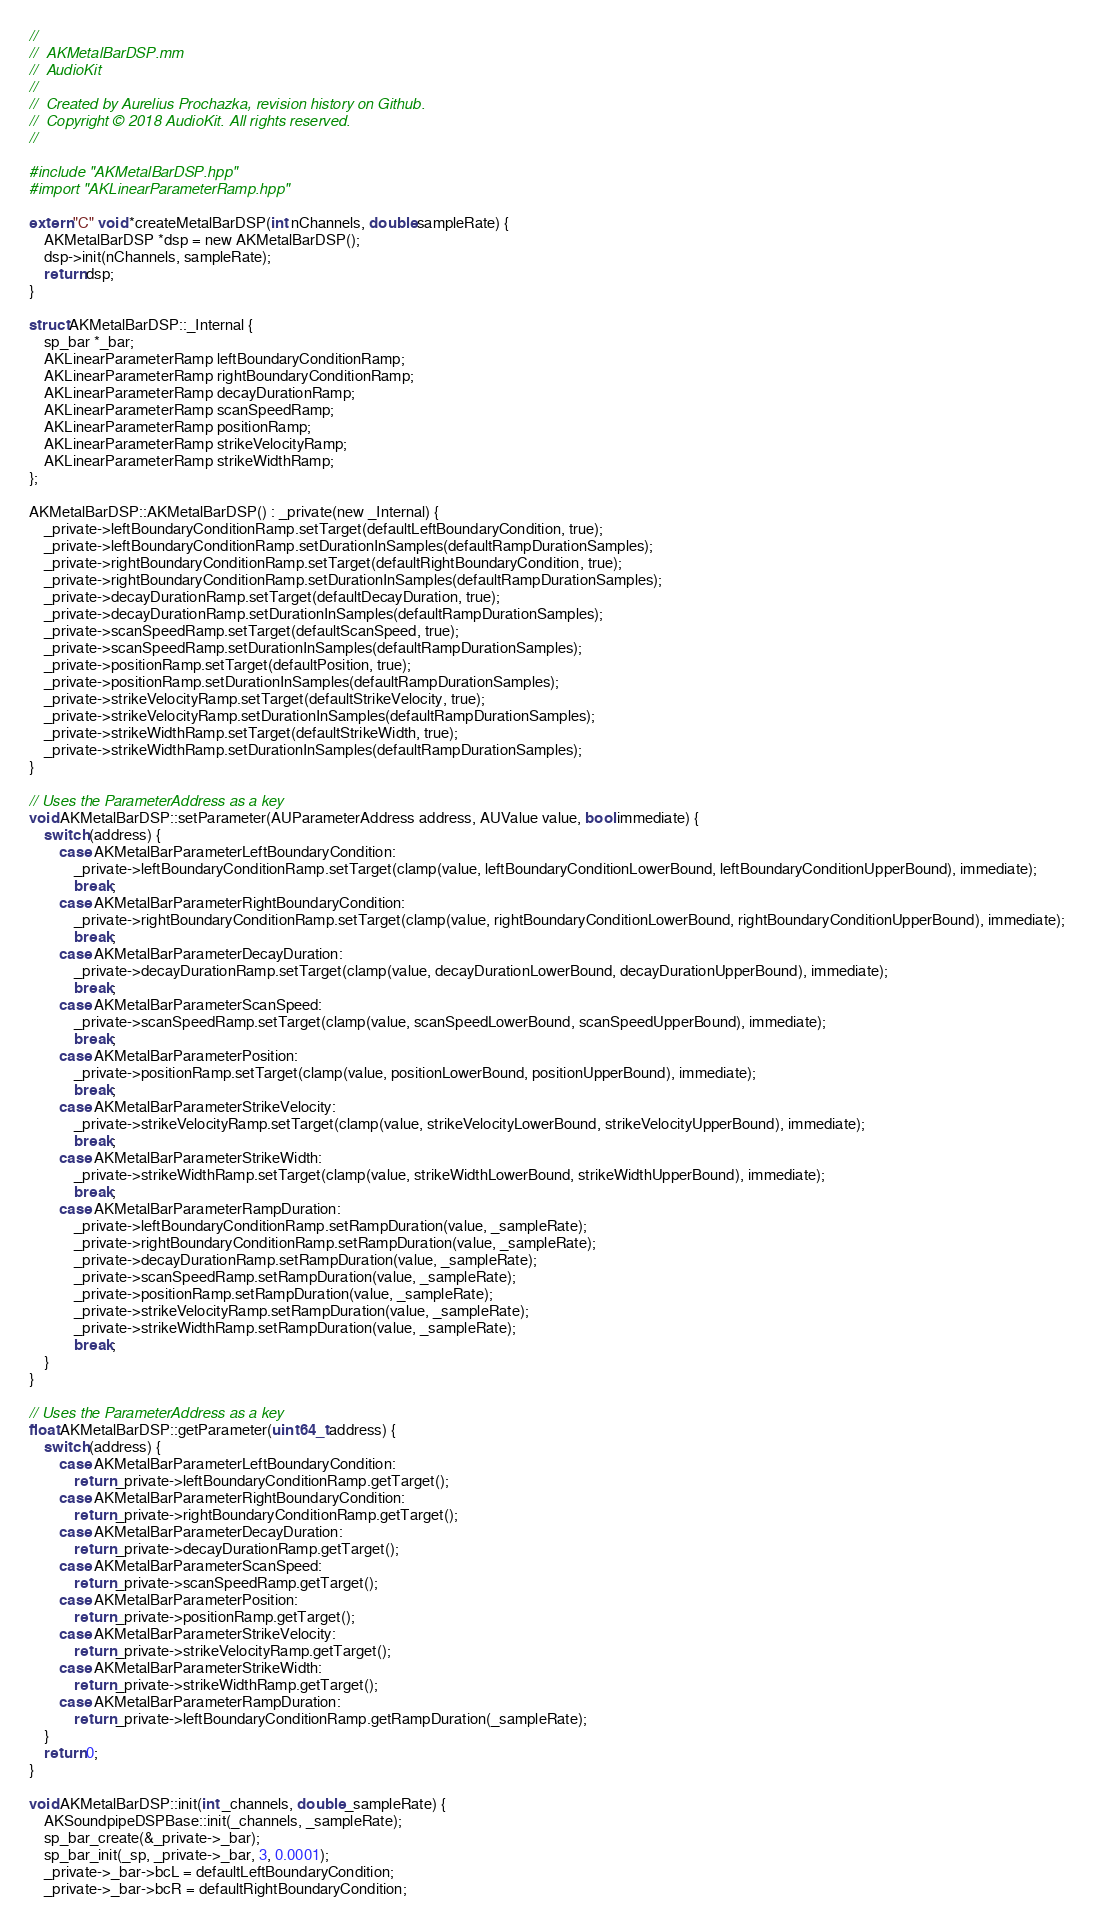<code> <loc_0><loc_0><loc_500><loc_500><_ObjectiveC_>//
//  AKMetalBarDSP.mm
//  AudioKit
//
//  Created by Aurelius Prochazka, revision history on Github.
//  Copyright © 2018 AudioKit. All rights reserved.
//

#include "AKMetalBarDSP.hpp"
#import "AKLinearParameterRamp.hpp"

extern "C" void *createMetalBarDSP(int nChannels, double sampleRate) {
    AKMetalBarDSP *dsp = new AKMetalBarDSP();
    dsp->init(nChannels, sampleRate);
    return dsp;
}

struct AKMetalBarDSP::_Internal {
    sp_bar *_bar;
    AKLinearParameterRamp leftBoundaryConditionRamp;
    AKLinearParameterRamp rightBoundaryConditionRamp;
    AKLinearParameterRamp decayDurationRamp;
    AKLinearParameterRamp scanSpeedRamp;
    AKLinearParameterRamp positionRamp;
    AKLinearParameterRamp strikeVelocityRamp;
    AKLinearParameterRamp strikeWidthRamp;
};

AKMetalBarDSP::AKMetalBarDSP() : _private(new _Internal) {
    _private->leftBoundaryConditionRamp.setTarget(defaultLeftBoundaryCondition, true);
    _private->leftBoundaryConditionRamp.setDurationInSamples(defaultRampDurationSamples);
    _private->rightBoundaryConditionRamp.setTarget(defaultRightBoundaryCondition, true);
    _private->rightBoundaryConditionRamp.setDurationInSamples(defaultRampDurationSamples);
    _private->decayDurationRamp.setTarget(defaultDecayDuration, true);
    _private->decayDurationRamp.setDurationInSamples(defaultRampDurationSamples);
    _private->scanSpeedRamp.setTarget(defaultScanSpeed, true);
    _private->scanSpeedRamp.setDurationInSamples(defaultRampDurationSamples);
    _private->positionRamp.setTarget(defaultPosition, true);
    _private->positionRamp.setDurationInSamples(defaultRampDurationSamples);
    _private->strikeVelocityRamp.setTarget(defaultStrikeVelocity, true);
    _private->strikeVelocityRamp.setDurationInSamples(defaultRampDurationSamples);
    _private->strikeWidthRamp.setTarget(defaultStrikeWidth, true);
    _private->strikeWidthRamp.setDurationInSamples(defaultRampDurationSamples);
}

// Uses the ParameterAddress as a key
void AKMetalBarDSP::setParameter(AUParameterAddress address, AUValue value, bool immediate) {
    switch (address) {
        case AKMetalBarParameterLeftBoundaryCondition:
            _private->leftBoundaryConditionRamp.setTarget(clamp(value, leftBoundaryConditionLowerBound, leftBoundaryConditionUpperBound), immediate);
            break;
        case AKMetalBarParameterRightBoundaryCondition:
            _private->rightBoundaryConditionRamp.setTarget(clamp(value, rightBoundaryConditionLowerBound, rightBoundaryConditionUpperBound), immediate);
            break;
        case AKMetalBarParameterDecayDuration:
            _private->decayDurationRamp.setTarget(clamp(value, decayDurationLowerBound, decayDurationUpperBound), immediate);
            break;
        case AKMetalBarParameterScanSpeed:
            _private->scanSpeedRamp.setTarget(clamp(value, scanSpeedLowerBound, scanSpeedUpperBound), immediate);
            break;
        case AKMetalBarParameterPosition:
            _private->positionRamp.setTarget(clamp(value, positionLowerBound, positionUpperBound), immediate);
            break;
        case AKMetalBarParameterStrikeVelocity:
            _private->strikeVelocityRamp.setTarget(clamp(value, strikeVelocityLowerBound, strikeVelocityUpperBound), immediate);
            break;
        case AKMetalBarParameterStrikeWidth:
            _private->strikeWidthRamp.setTarget(clamp(value, strikeWidthLowerBound, strikeWidthUpperBound), immediate);
            break;
        case AKMetalBarParameterRampDuration:
            _private->leftBoundaryConditionRamp.setRampDuration(value, _sampleRate);
            _private->rightBoundaryConditionRamp.setRampDuration(value, _sampleRate);
            _private->decayDurationRamp.setRampDuration(value, _sampleRate);
            _private->scanSpeedRamp.setRampDuration(value, _sampleRate);
            _private->positionRamp.setRampDuration(value, _sampleRate);
            _private->strikeVelocityRamp.setRampDuration(value, _sampleRate);
            _private->strikeWidthRamp.setRampDuration(value, _sampleRate);
            break;
    }
}

// Uses the ParameterAddress as a key
float AKMetalBarDSP::getParameter(uint64_t address) {
    switch (address) {
        case AKMetalBarParameterLeftBoundaryCondition:
            return _private->leftBoundaryConditionRamp.getTarget();
        case AKMetalBarParameterRightBoundaryCondition:
            return _private->rightBoundaryConditionRamp.getTarget();
        case AKMetalBarParameterDecayDuration:
            return _private->decayDurationRamp.getTarget();
        case AKMetalBarParameterScanSpeed:
            return _private->scanSpeedRamp.getTarget();
        case AKMetalBarParameterPosition:
            return _private->positionRamp.getTarget();
        case AKMetalBarParameterStrikeVelocity:
            return _private->strikeVelocityRamp.getTarget();
        case AKMetalBarParameterStrikeWidth:
            return _private->strikeWidthRamp.getTarget();
        case AKMetalBarParameterRampDuration:
            return _private->leftBoundaryConditionRamp.getRampDuration(_sampleRate);
    }
    return 0;
}

void AKMetalBarDSP::init(int _channels, double _sampleRate) {
    AKSoundpipeDSPBase::init(_channels, _sampleRate);
    sp_bar_create(&_private->_bar);
    sp_bar_init(_sp, _private->_bar, 3, 0.0001);
    _private->_bar->bcL = defaultLeftBoundaryCondition;
    _private->_bar->bcR = defaultRightBoundaryCondition;</code> 